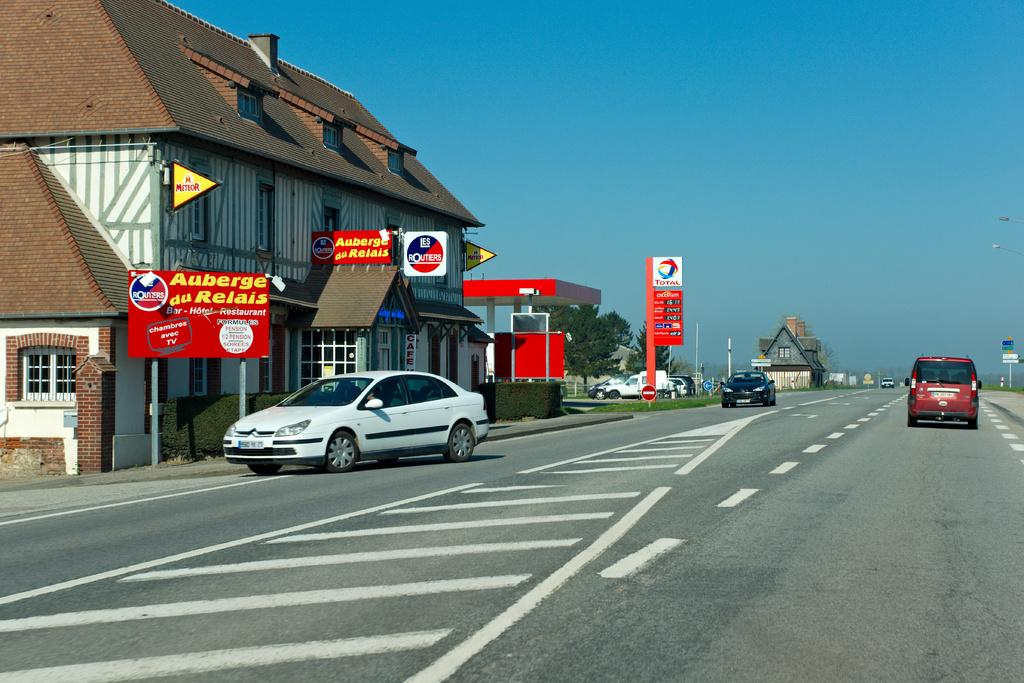What type of vehicles can be seen on the road in the image? There are cars on the road in the image. What can be seen in the distance behind the cars? There are buildings visible in the background of the image. What is the purpose of the structure with pumps and a sign in the image? There is a petrol bunk in the image, which is used for refueling vehicles. What are the tall, thin objects with signs on them in the image? There are boards on poles in the image, which may be used for advertising or providing information. What government policy is being discussed on the boards on poles in the image? There is no indication of any government policy being discussed on the boards on poles in the image. 